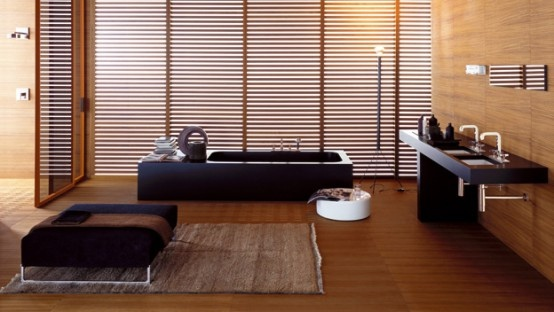Describe the objects in this image and their specific colors. I can see bed in beige, black, maroon, brown, and gray tones and sink in beige, black, gray, darkgray, and maroon tones in this image. 